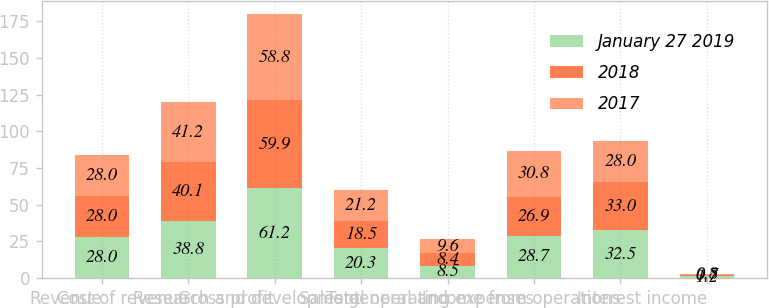Convert chart. <chart><loc_0><loc_0><loc_500><loc_500><stacked_bar_chart><ecel><fcel>Revenue<fcel>Cost of revenue<fcel>Gross profit<fcel>Research and development<fcel>Sales general and<fcel>Total operating expenses<fcel>Income from operations<fcel>Interest income<nl><fcel>January 27 2019<fcel>28<fcel>38.8<fcel>61.2<fcel>20.3<fcel>8.5<fcel>28.7<fcel>32.5<fcel>1.2<nl><fcel>2018<fcel>28<fcel>40.1<fcel>59.9<fcel>18.5<fcel>8.4<fcel>26.9<fcel>33<fcel>0.7<nl><fcel>2017<fcel>28<fcel>41.2<fcel>58.8<fcel>21.2<fcel>9.6<fcel>30.8<fcel>28<fcel>0.8<nl></chart> 